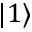<formula> <loc_0><loc_0><loc_500><loc_500>| 1 \rangle</formula> 